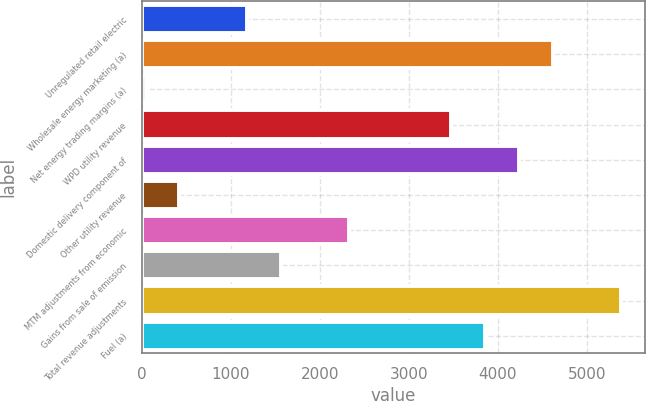Convert chart to OTSL. <chart><loc_0><loc_0><loc_500><loc_500><bar_chart><fcel>Unregulated retail electric<fcel>Wholesale energy marketing (a)<fcel>Net energy trading margins (a)<fcel>WPD utility revenue<fcel>Domestic delivery component of<fcel>Other utility revenue<fcel>MTM adjustments from economic<fcel>Gains from sale of emission<fcel>Total revenue adjustments<fcel>Fuel (a)<nl><fcel>1185.2<fcel>4617.8<fcel>41<fcel>3473.6<fcel>4236.4<fcel>422.4<fcel>2329.4<fcel>1566.6<fcel>5380.6<fcel>3855<nl></chart> 